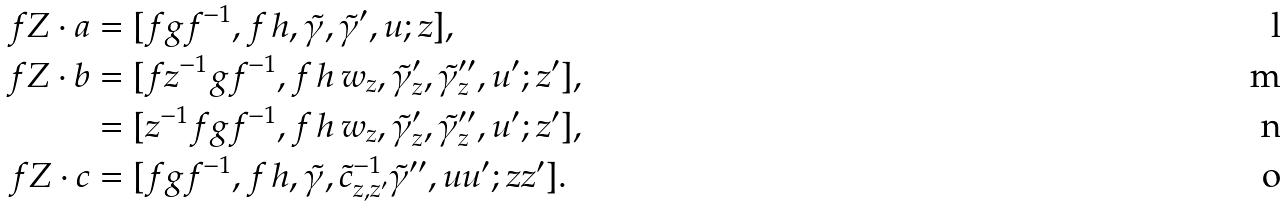Convert formula to latex. <formula><loc_0><loc_0><loc_500><loc_500>f Z \cdot a & = [ f g f ^ { - 1 } , f \, h , \tilde { \gamma } , \tilde { \gamma } ^ { \prime } , u ; z ] , \\ f Z \cdot b & = [ f z ^ { - 1 } g f ^ { - 1 } , f \, h \, w _ { z } , \tilde { \gamma } _ { z } ^ { \prime } , \tilde { \gamma } _ { z } ^ { \prime \prime } , u ^ { \prime } ; z ^ { \prime } ] , \\ & = [ z ^ { - 1 } f g f ^ { - 1 } , f \, h \, w _ { z } , \tilde { \gamma } _ { z } ^ { \prime } , \tilde { \gamma } _ { z } ^ { \prime \prime } , u ^ { \prime } ; z ^ { \prime } ] , \\ f Z \cdot c & = [ f g f ^ { - 1 } , f \, h , \tilde { \gamma } , \tilde { c } _ { z , z ^ { \prime } } ^ { - 1 } \tilde { \gamma } ^ { \prime \prime } , u u ^ { \prime } ; z z ^ { \prime } ] .</formula> 